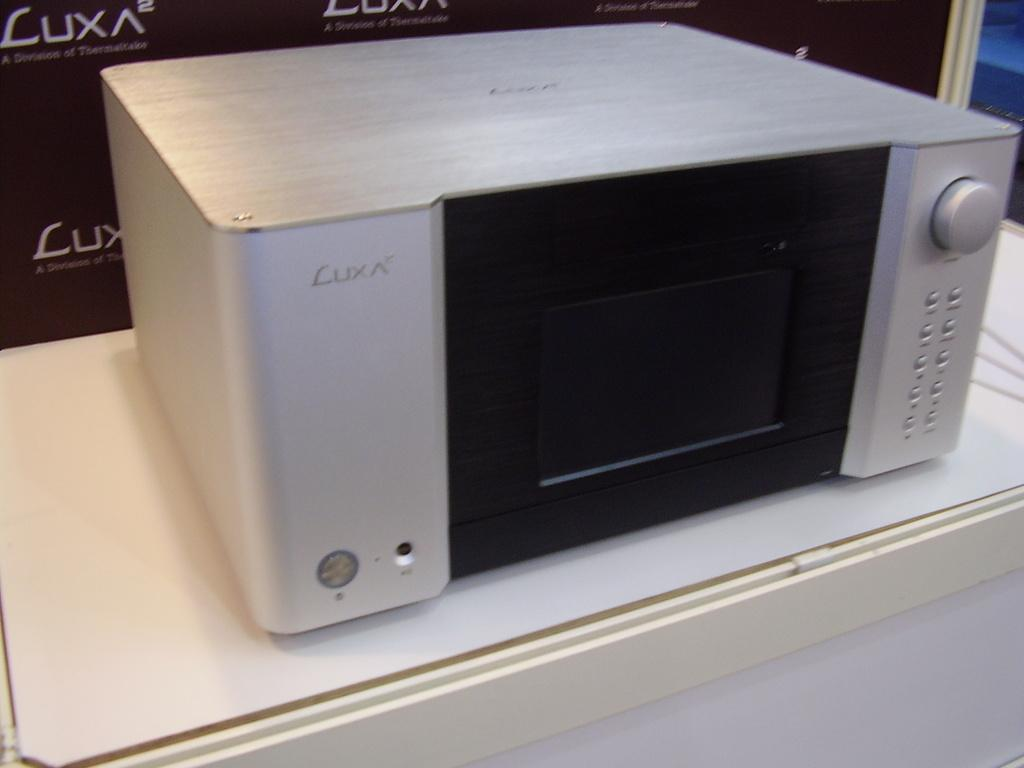<image>
Provide a brief description of the given image. a small box with the logo on it that says 'luxa' 